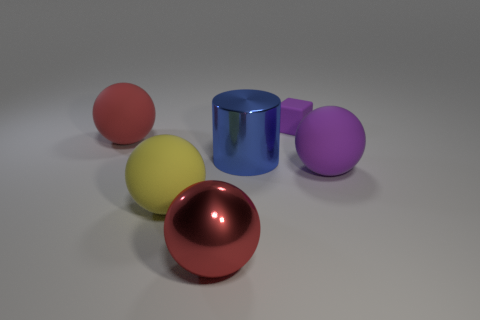Subtract all large red rubber spheres. How many spheres are left? 3 Subtract 1 blocks. How many blocks are left? 0 Add 1 purple things. How many objects exist? 7 Subtract all purple spheres. How many spheres are left? 3 Subtract all spheres. How many objects are left? 2 Subtract all yellow blocks. How many yellow balls are left? 1 Subtract all gray cylinders. Subtract all gray blocks. How many cylinders are left? 1 Subtract all big red objects. Subtract all blue shiny objects. How many objects are left? 3 Add 2 big cylinders. How many big cylinders are left? 3 Add 3 cyan shiny spheres. How many cyan shiny spheres exist? 3 